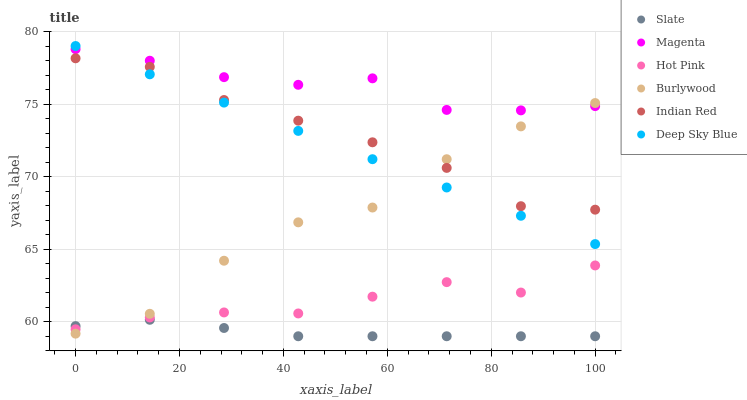Does Slate have the minimum area under the curve?
Answer yes or no. Yes. Does Magenta have the maximum area under the curve?
Answer yes or no. Yes. Does Burlywood have the minimum area under the curve?
Answer yes or no. No. Does Burlywood have the maximum area under the curve?
Answer yes or no. No. Is Deep Sky Blue the smoothest?
Answer yes or no. Yes. Is Burlywood the roughest?
Answer yes or no. Yes. Is Slate the smoothest?
Answer yes or no. No. Is Slate the roughest?
Answer yes or no. No. Does Slate have the lowest value?
Answer yes or no. Yes. Does Burlywood have the lowest value?
Answer yes or no. No. Does Deep Sky Blue have the highest value?
Answer yes or no. Yes. Does Burlywood have the highest value?
Answer yes or no. No. Is Hot Pink less than Indian Red?
Answer yes or no. Yes. Is Deep Sky Blue greater than Slate?
Answer yes or no. Yes. Does Deep Sky Blue intersect Burlywood?
Answer yes or no. Yes. Is Deep Sky Blue less than Burlywood?
Answer yes or no. No. Is Deep Sky Blue greater than Burlywood?
Answer yes or no. No. Does Hot Pink intersect Indian Red?
Answer yes or no. No. 